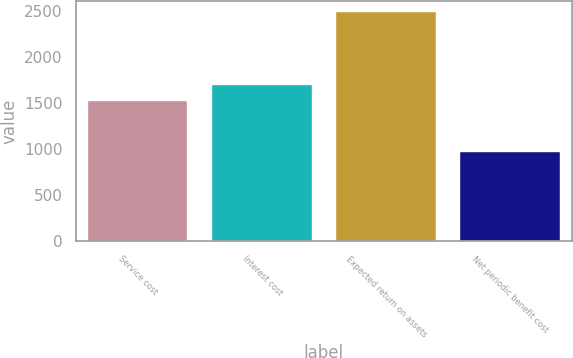Convert chart to OTSL. <chart><loc_0><loc_0><loc_500><loc_500><bar_chart><fcel>Service cost<fcel>Interest cost<fcel>Expected return on assets<fcel>Net periodic benefit cost<nl><fcel>1527<fcel>1694<fcel>2489<fcel>970<nl></chart> 